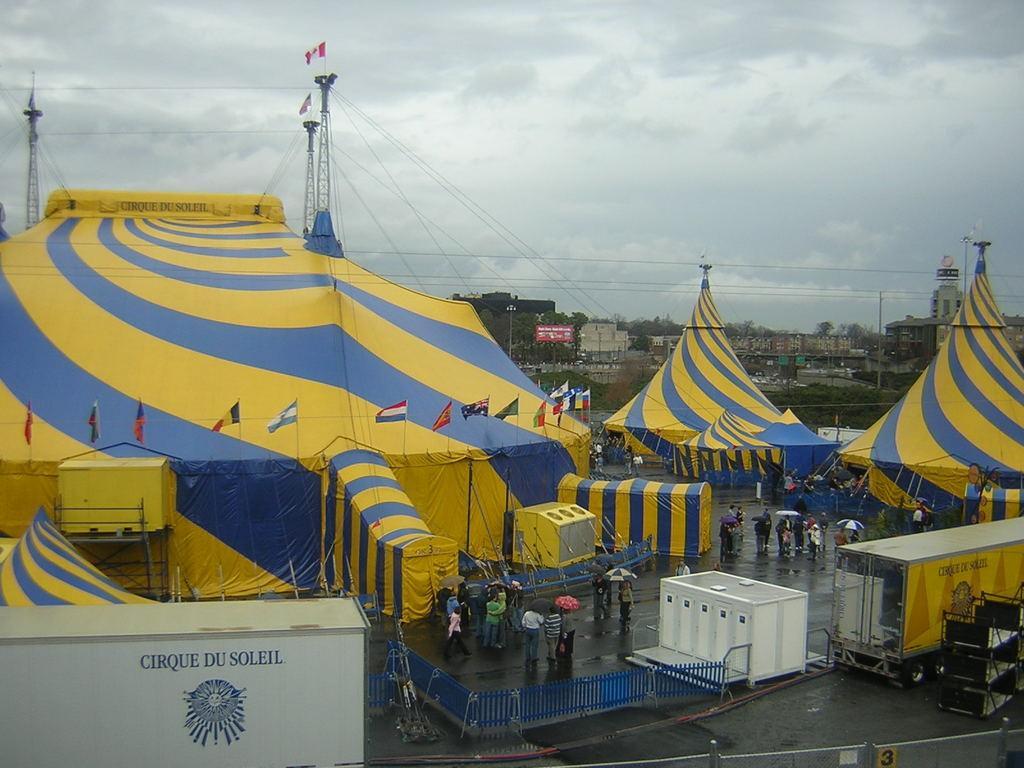In one or two sentences, can you explain what this image depicts? In the picture I can see tents, flags and people standing on the ground among them some are holding umbrellas in hands. I can also see fence, trees, poles, wires attached to towers, buildings and some other objects on the ground. In the background I can see the sky. 